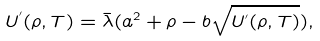Convert formula to latex. <formula><loc_0><loc_0><loc_500><loc_500>U ^ { ^ { \prime } } ( \rho , T ) = \bar { \lambda } ( a ^ { 2 } + \rho - b \sqrt { U ^ { ^ { \prime } } ( \rho , T ) } ) ,</formula> 